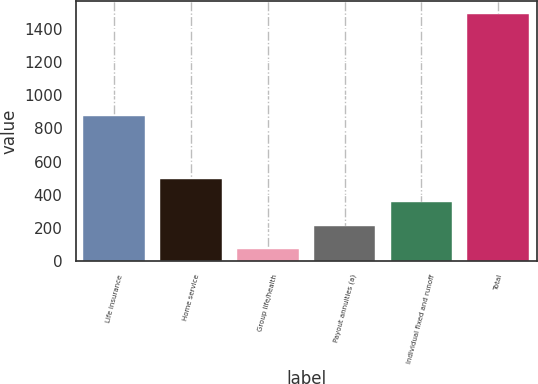<chart> <loc_0><loc_0><loc_500><loc_500><bar_chart><fcel>Life insurance<fcel>Home service<fcel>Group life/health<fcel>Payout annuities (a)<fcel>Individual fixed and runoff<fcel>Total<nl><fcel>874<fcel>496.8<fcel>69<fcel>211.6<fcel>354.2<fcel>1495<nl></chart> 